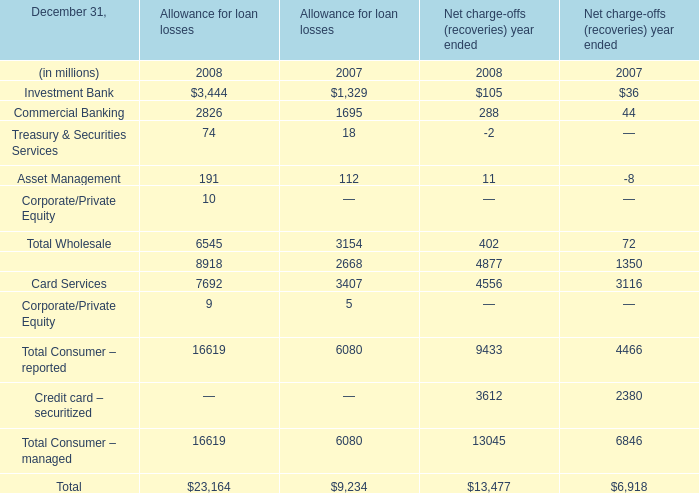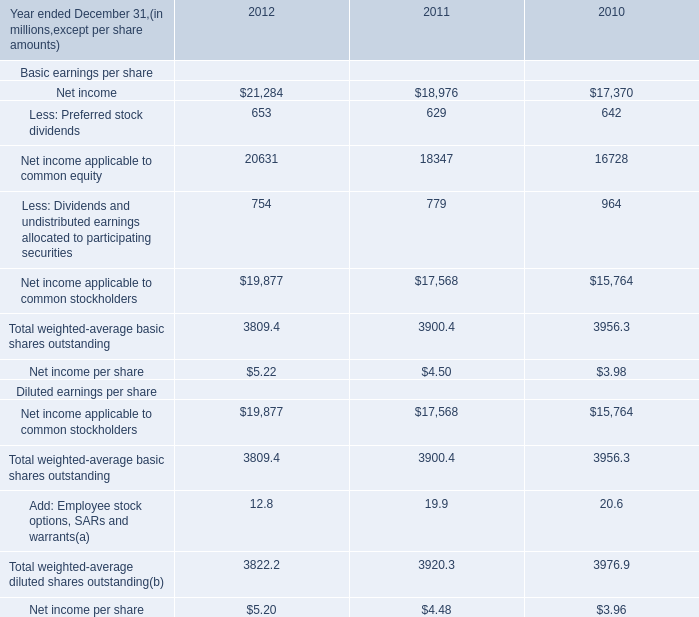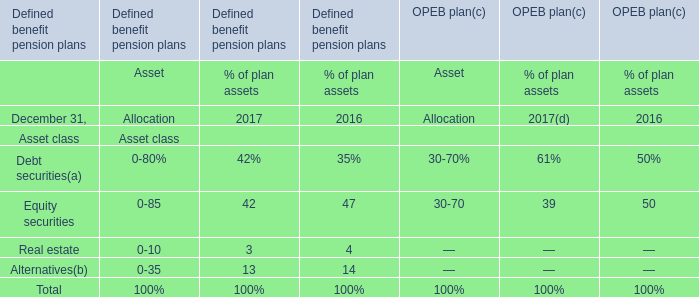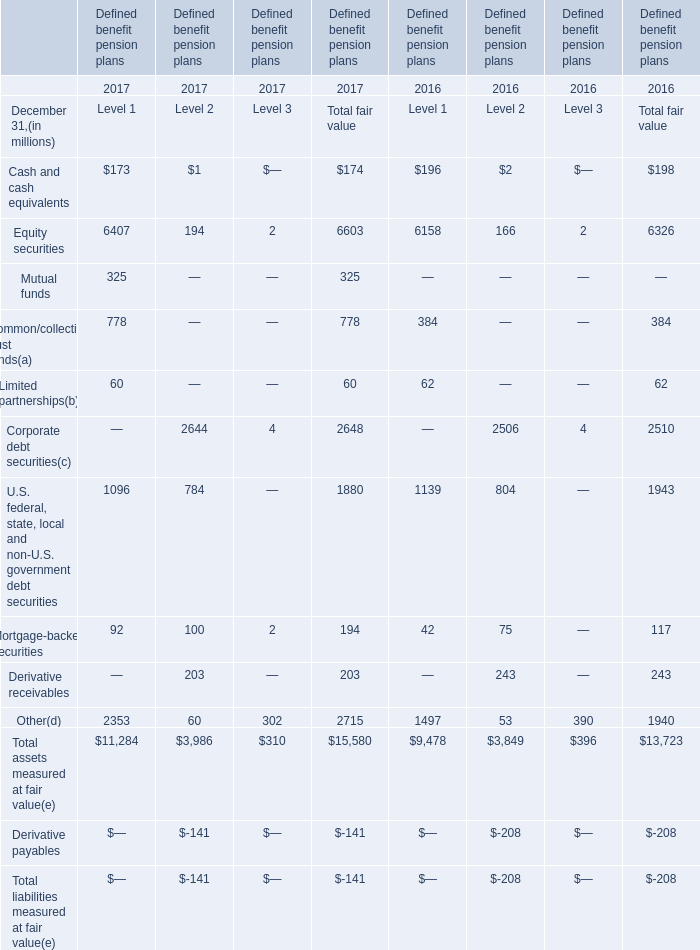In the year with largest amount of Retail Financial Services of Net charge-offs (recoveries) year ended, what's the increasing rate of Total Wholesale? (in %) 
Computations: ((402 - 72) / 72)
Answer: 4.58333. 